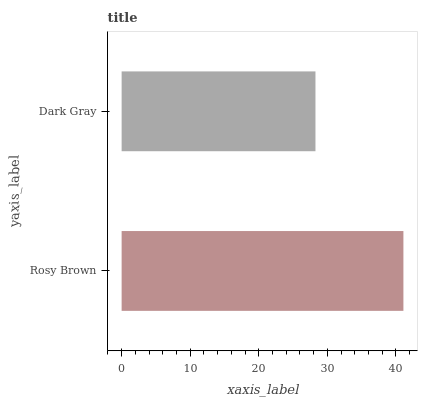Is Dark Gray the minimum?
Answer yes or no. Yes. Is Rosy Brown the maximum?
Answer yes or no. Yes. Is Dark Gray the maximum?
Answer yes or no. No. Is Rosy Brown greater than Dark Gray?
Answer yes or no. Yes. Is Dark Gray less than Rosy Brown?
Answer yes or no. Yes. Is Dark Gray greater than Rosy Brown?
Answer yes or no. No. Is Rosy Brown less than Dark Gray?
Answer yes or no. No. Is Rosy Brown the high median?
Answer yes or no. Yes. Is Dark Gray the low median?
Answer yes or no. Yes. Is Dark Gray the high median?
Answer yes or no. No. Is Rosy Brown the low median?
Answer yes or no. No. 